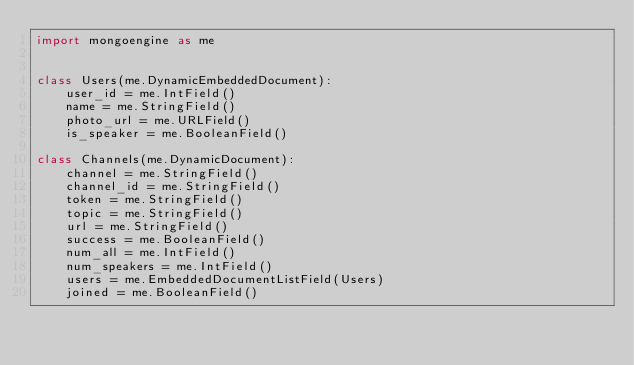Convert code to text. <code><loc_0><loc_0><loc_500><loc_500><_Python_>import mongoengine as me


class Users(me.DynamicEmbeddedDocument):
    user_id = me.IntField()
    name = me.StringField()
    photo_url = me.URLField()
    is_speaker = me.BooleanField()

class Channels(me.DynamicDocument):
    channel = me.StringField()
    channel_id = me.StringField()
    token = me.StringField()
    topic = me.StringField()
    url = me.StringField()
    success = me.BooleanField()
    num_all = me.IntField()
    num_speakers = me.IntField()
    users = me.EmbeddedDocumentListField(Users)
    joined = me.BooleanField()</code> 